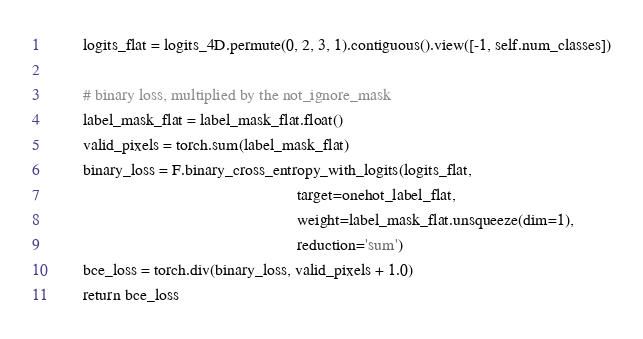<code> <loc_0><loc_0><loc_500><loc_500><_Python_>		logits_flat = logits_4D.permute(0, 2, 3, 1).contiguous().view([-1, self.num_classes])

		# binary loss, multiplied by the not_ignore_mask
		label_mask_flat = label_mask_flat.float()
		valid_pixels = torch.sum(label_mask_flat)
		binary_loss = F.binary_cross_entropy_with_logits(logits_flat,
															target=onehot_label_flat,
															weight=label_mask_flat.unsqueeze(dim=1),
															reduction='sum')
		bce_loss = torch.div(binary_loss, valid_pixels + 1.0)
		return bce_loss
</code> 